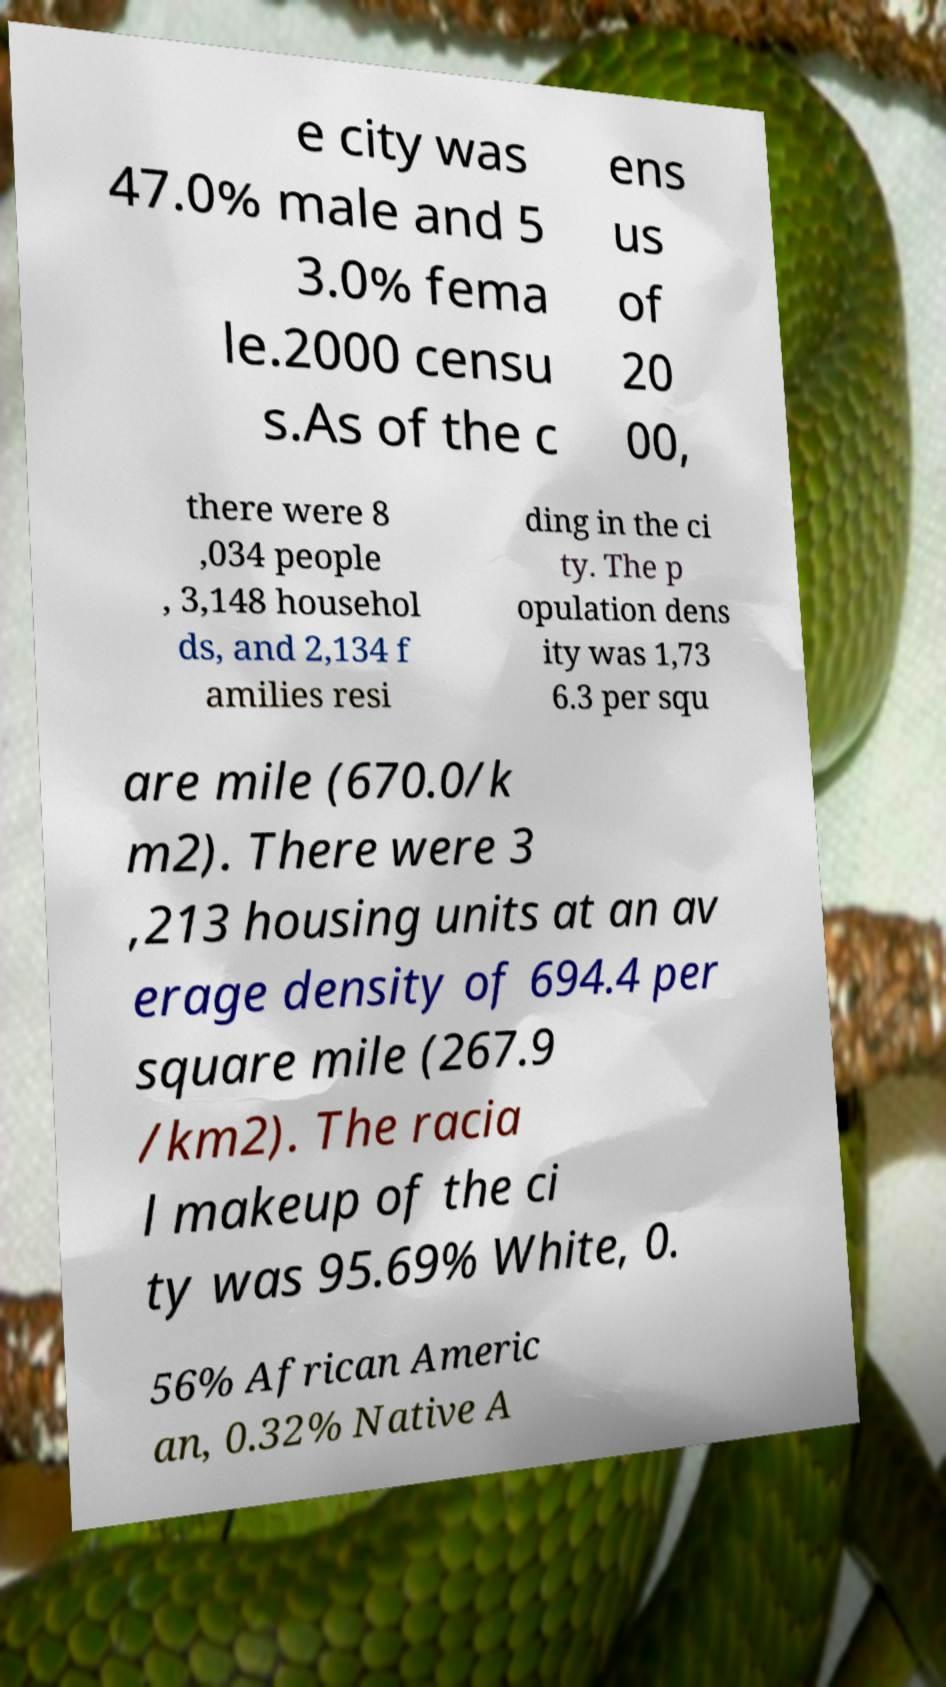Could you assist in decoding the text presented in this image and type it out clearly? e city was 47.0% male and 5 3.0% fema le.2000 censu s.As of the c ens us of 20 00, there were 8 ,034 people , 3,148 househol ds, and 2,134 f amilies resi ding in the ci ty. The p opulation dens ity was 1,73 6.3 per squ are mile (670.0/k m2). There were 3 ,213 housing units at an av erage density of 694.4 per square mile (267.9 /km2). The racia l makeup of the ci ty was 95.69% White, 0. 56% African Americ an, 0.32% Native A 